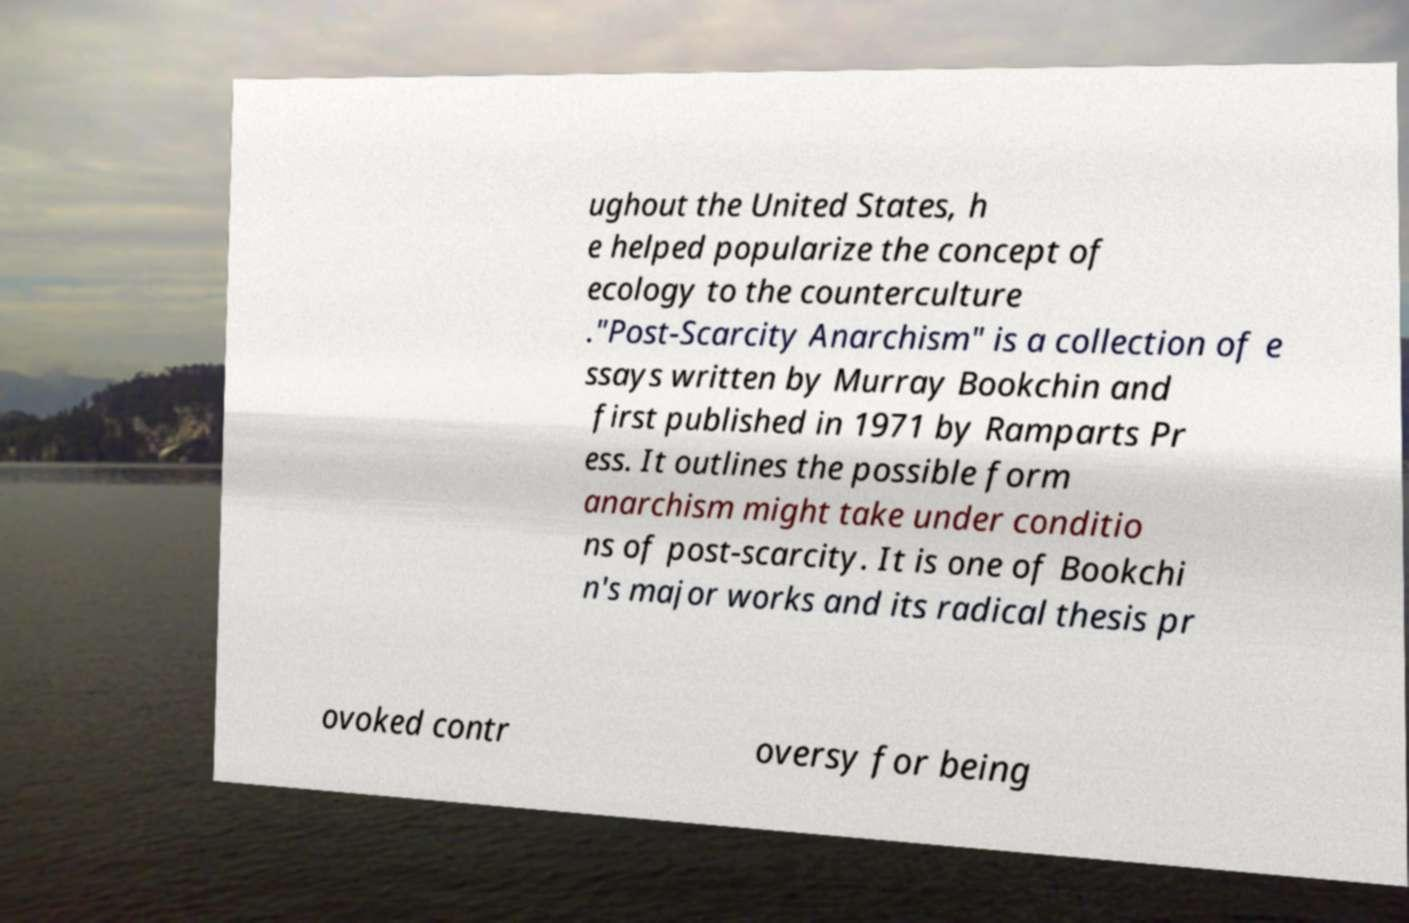Please read and relay the text visible in this image. What does it say? ughout the United States, h e helped popularize the concept of ecology to the counterculture ."Post-Scarcity Anarchism" is a collection of e ssays written by Murray Bookchin and first published in 1971 by Ramparts Pr ess. It outlines the possible form anarchism might take under conditio ns of post-scarcity. It is one of Bookchi n's major works and its radical thesis pr ovoked contr oversy for being 